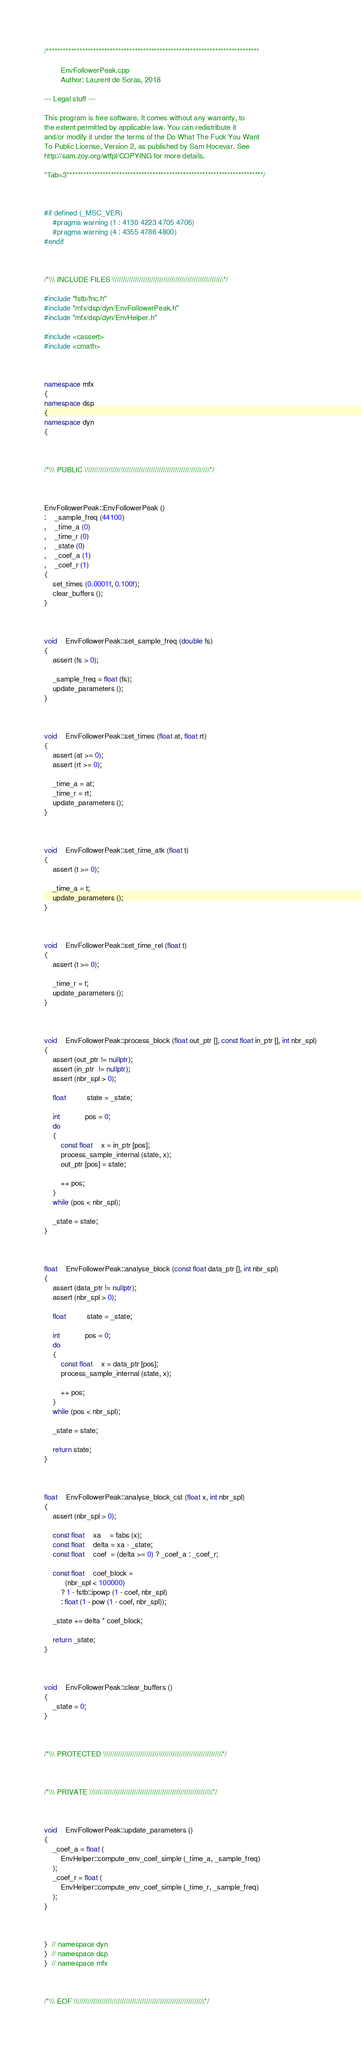Convert code to text. <code><loc_0><loc_0><loc_500><loc_500><_C++_>/*****************************************************************************

        EnvFollowerPeak.cpp
        Author: Laurent de Soras, 2018

--- Legal stuff ---

This program is free software. It comes without any warranty, to
the extent permitted by applicable law. You can redistribute it
and/or modify it under the terms of the Do What The Fuck You Want
To Public License, Version 2, as published by Sam Hocevar. See
http://sam.zoy.org/wtfpl/COPYING for more details.

*Tab=3***********************************************************************/



#if defined (_MSC_VER)
	#pragma warning (1 : 4130 4223 4705 4706)
	#pragma warning (4 : 4355 4786 4800)
#endif



/*\\\ INCLUDE FILES \\\\\\\\\\\\\\\\\\\\\\\\\\\\\\\\\\\\\\\\\\\\\\\\\\\\\\\\*/

#include "fstb/fnc.h"
#include "mfx/dsp/dyn/EnvFollowerPeak.h"
#include "mfx/dsp/dyn/EnvHelper.h"

#include <cassert>
#include <cmath>



namespace mfx
{
namespace dsp
{
namespace dyn
{



/*\\\ PUBLIC \\\\\\\\\\\\\\\\\\\\\\\\\\\\\\\\\\\\\\\\\\\\\\\\\\\\\\\\\\\\\\\*/



EnvFollowerPeak::EnvFollowerPeak ()
:	_sample_freq (44100)
,	_time_a (0)
,	_time_r (0)
,	_state (0)
,	_coef_a (1)
,	_coef_r (1)
{
	set_times (0.0001f, 0.100f);
	clear_buffers ();
}



void	EnvFollowerPeak::set_sample_freq (double fs)
{
	assert (fs > 0);

	_sample_freq = float (fs);
	update_parameters ();
}



void	EnvFollowerPeak::set_times (float at, float rt)
{
	assert (at >= 0);
	assert (rt >= 0);

	_time_a = at;
	_time_r = rt;
	update_parameters ();
}



void	EnvFollowerPeak::set_time_atk (float t)
{
	assert (t >= 0);

	_time_a = t;
	update_parameters ();
}



void	EnvFollowerPeak::set_time_rel (float t)
{
	assert (t >= 0);

	_time_r = t;
	update_parameters ();
}



void	EnvFollowerPeak::process_block (float out_ptr [], const float in_ptr [], int nbr_spl)
{
	assert (out_ptr != nullptr);
	assert (in_ptr  != nullptr);
	assert (nbr_spl > 0);

	float          state = _state;

	int            pos = 0;
	do
	{
		const float    x = in_ptr [pos];
		process_sample_internal (state, x);
		out_ptr [pos] = state;

		++ pos;
	}
	while (pos < nbr_spl);

	_state = state;
}



float	EnvFollowerPeak::analyse_block (const float data_ptr [], int nbr_spl)
{
	assert (data_ptr != nullptr);
	assert (nbr_spl > 0);

	float          state = _state;

	int            pos = 0;
	do
	{
		const float    x = data_ptr [pos];
		process_sample_internal (state, x);

		++ pos;
	}
	while (pos < nbr_spl);

	_state = state;

	return state;
}



float	EnvFollowerPeak::analyse_block_cst (float x, int nbr_spl)
{
	assert (nbr_spl > 0);

	const float    xa    = fabs (x);
	const float    delta = xa - _state;
	const float    coef  = (delta >= 0) ? _coef_a : _coef_r;

	const float    coef_block =
		  (nbr_spl < 100000)
		? 1 - fstb::ipowp (1 - coef, nbr_spl)
		: float (1 - pow (1 - coef, nbr_spl));

	_state += delta * coef_block;

	return _state;
}



void	EnvFollowerPeak::clear_buffers ()
{
	_state = 0;
}



/*\\\ PROTECTED \\\\\\\\\\\\\\\\\\\\\\\\\\\\\\\\\\\\\\\\\\\\\\\\\\\\\\\\\\\\*/



/*\\\ PRIVATE \\\\\\\\\\\\\\\\\\\\\\\\\\\\\\\\\\\\\\\\\\\\\\\\\\\\\\\\\\\\\\*/



void	EnvFollowerPeak::update_parameters ()
{
	_coef_a = float (
		EnvHelper::compute_env_coef_simple (_time_a, _sample_freq)
	);
	_coef_r = float (
		EnvHelper::compute_env_coef_simple (_time_r, _sample_freq)
	);
}



}  // namespace dyn
}  // namespace dsp
}  // namespace mfx



/*\\\ EOF \\\\\\\\\\\\\\\\\\\\\\\\\\\\\\\\\\\\\\\\\\\\\\\\\\\\\\\\\\\\\\\\\\*/
</code> 